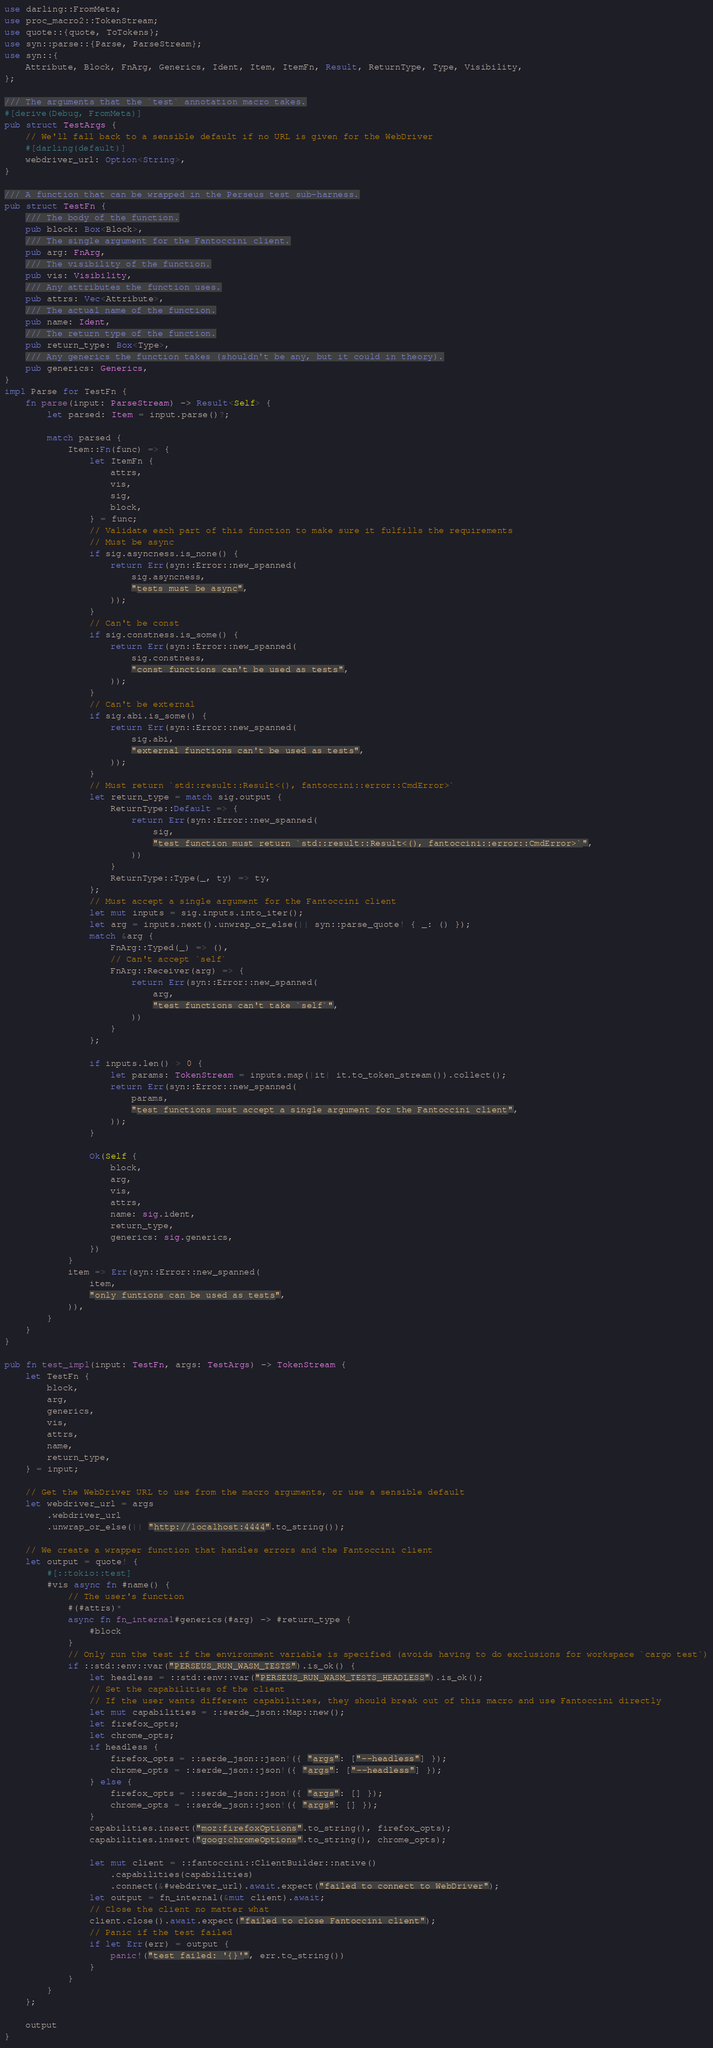Convert code to text. <code><loc_0><loc_0><loc_500><loc_500><_Rust_>use darling::FromMeta;
use proc_macro2::TokenStream;
use quote::{quote, ToTokens};
use syn::parse::{Parse, ParseStream};
use syn::{
    Attribute, Block, FnArg, Generics, Ident, Item, ItemFn, Result, ReturnType, Type, Visibility,
};

/// The arguments that the `test` annotation macro takes.
#[derive(Debug, FromMeta)]
pub struct TestArgs {
    // We'll fall back to a sensible default if no URL is given for the WebDriver
    #[darling(default)]
    webdriver_url: Option<String>,
}

/// A function that can be wrapped in the Perseus test sub-harness.
pub struct TestFn {
    /// The body of the function.
    pub block: Box<Block>,
    /// The single argument for the Fantoccini client.
    pub arg: FnArg,
    /// The visibility of the function.
    pub vis: Visibility,
    /// Any attributes the function uses.
    pub attrs: Vec<Attribute>,
    /// The actual name of the function.
    pub name: Ident,
    /// The return type of the function.
    pub return_type: Box<Type>,
    /// Any generics the function takes (shouldn't be any, but it could in theory).
    pub generics: Generics,
}
impl Parse for TestFn {
    fn parse(input: ParseStream) -> Result<Self> {
        let parsed: Item = input.parse()?;

        match parsed {
            Item::Fn(func) => {
                let ItemFn {
                    attrs,
                    vis,
                    sig,
                    block,
                } = func;
                // Validate each part of this function to make sure it fulfills the requirements
                // Must be async
                if sig.asyncness.is_none() {
                    return Err(syn::Error::new_spanned(
                        sig.asyncness,
                        "tests must be async",
                    ));
                }
                // Can't be const
                if sig.constness.is_some() {
                    return Err(syn::Error::new_spanned(
                        sig.constness,
                        "const functions can't be used as tests",
                    ));
                }
                // Can't be external
                if sig.abi.is_some() {
                    return Err(syn::Error::new_spanned(
                        sig.abi,
                        "external functions can't be used as tests",
                    ));
                }
                // Must return `std::result::Result<(), fantoccini::error::CmdError>`
                let return_type = match sig.output {
                    ReturnType::Default => {
                        return Err(syn::Error::new_spanned(
                            sig,
                            "test function must return `std::result::Result<(), fantoccini::error::CmdError>`",
                        ))
                    }
                    ReturnType::Type(_, ty) => ty,
                };
                // Must accept a single argument for the Fantoccini client
                let mut inputs = sig.inputs.into_iter();
                let arg = inputs.next().unwrap_or_else(|| syn::parse_quote! { _: () });
                match &arg {
                    FnArg::Typed(_) => (),
                    // Can't accept `self`
                    FnArg::Receiver(arg) => {
                        return Err(syn::Error::new_spanned(
                            arg,
                            "test functions can't take `self`",
                        ))
                    }
                };

                if inputs.len() > 0 {
                    let params: TokenStream = inputs.map(|it| it.to_token_stream()).collect();
                    return Err(syn::Error::new_spanned(
                        params,
                        "test functions must accept a single argument for the Fantoccini client",
                    ));
                }

                Ok(Self {
                    block,
                    arg,
                    vis,
                    attrs,
                    name: sig.ident,
                    return_type,
                    generics: sig.generics,
                })
            }
            item => Err(syn::Error::new_spanned(
                item,
                "only funtions can be used as tests",
            )),
        }
    }
}

pub fn test_impl(input: TestFn, args: TestArgs) -> TokenStream {
    let TestFn {
        block,
        arg,
        generics,
        vis,
        attrs,
        name,
        return_type,
    } = input;

    // Get the WebDriver URL to use from the macro arguments, or use a sensible default
    let webdriver_url = args
        .webdriver_url
        .unwrap_or_else(|| "http://localhost:4444".to_string());

    // We create a wrapper function that handles errors and the Fantoccini client
    let output = quote! {
        #[::tokio::test]
        #vis async fn #name() {
            // The user's function
            #(#attrs)*
            async fn fn_internal#generics(#arg) -> #return_type {
                #block
            }
            // Only run the test if the environment variable is specified (avoids having to do exclusions for workspace `cargo test`)
            if ::std::env::var("PERSEUS_RUN_WASM_TESTS").is_ok() {
                let headless = ::std::env::var("PERSEUS_RUN_WASM_TESTS_HEADLESS").is_ok();
                // Set the capabilities of the client
                // If the user wants different capabilities, they should break out of this macro and use Fantoccini directly
                let mut capabilities = ::serde_json::Map::new();
                let firefox_opts;
                let chrome_opts;
                if headless {
                    firefox_opts = ::serde_json::json!({ "args": ["--headless"] });
                    chrome_opts = ::serde_json::json!({ "args": ["--headless"] });
                } else {
                    firefox_opts = ::serde_json::json!({ "args": [] });
                    chrome_opts = ::serde_json::json!({ "args": [] });
                }
                capabilities.insert("moz:firefoxOptions".to_string(), firefox_opts);
                capabilities.insert("goog:chromeOptions".to_string(), chrome_opts);

                let mut client = ::fantoccini::ClientBuilder::native()
                    .capabilities(capabilities)
                    .connect(&#webdriver_url).await.expect("failed to connect to WebDriver");
                let output = fn_internal(&mut client).await;
                // Close the client no matter what
                client.close().await.expect("failed to close Fantoccini client");
                // Panic if the test failed
                if let Err(err) = output {
                    panic!("test failed: '{}'", err.to_string())
                }
            }
        }
    };

    output
}
</code> 